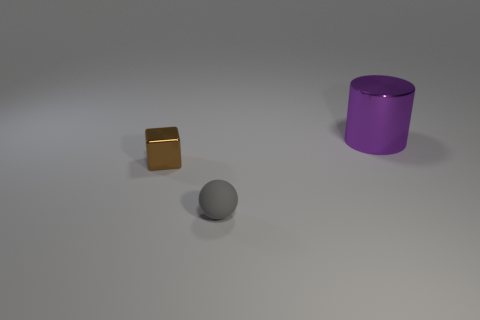Subtract all balls. How many objects are left? 2 Add 1 yellow matte balls. How many objects exist? 4 Subtract 1 cubes. How many cubes are left? 0 Add 2 red blocks. How many red blocks exist? 2 Subtract 0 green balls. How many objects are left? 3 Subtract all red spheres. Subtract all cyan cylinders. How many spheres are left? 1 Subtract all gray cylinders. How many blue balls are left? 0 Subtract all brown metallic cubes. Subtract all tiny things. How many objects are left? 0 Add 3 small brown metal cubes. How many small brown metal cubes are left? 4 